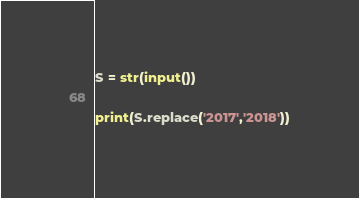<code> <loc_0><loc_0><loc_500><loc_500><_Python_>S = str(input())

print(S.replace('2017','2018'))</code> 